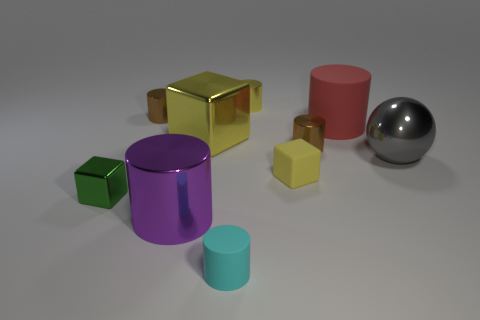Subtract all big cylinders. How many cylinders are left? 4 Subtract all red cylinders. How many cylinders are left? 5 Subtract 3 cylinders. How many cylinders are left? 3 Subtract all rubber cubes. Subtract all tiny brown metallic objects. How many objects are left? 7 Add 4 brown cylinders. How many brown cylinders are left? 6 Add 2 tiny brown shiny things. How many tiny brown shiny things exist? 4 Subtract 1 yellow cylinders. How many objects are left? 9 Subtract all cylinders. How many objects are left? 4 Subtract all purple spheres. Subtract all blue cylinders. How many spheres are left? 1 Subtract all gray cubes. How many yellow balls are left? 0 